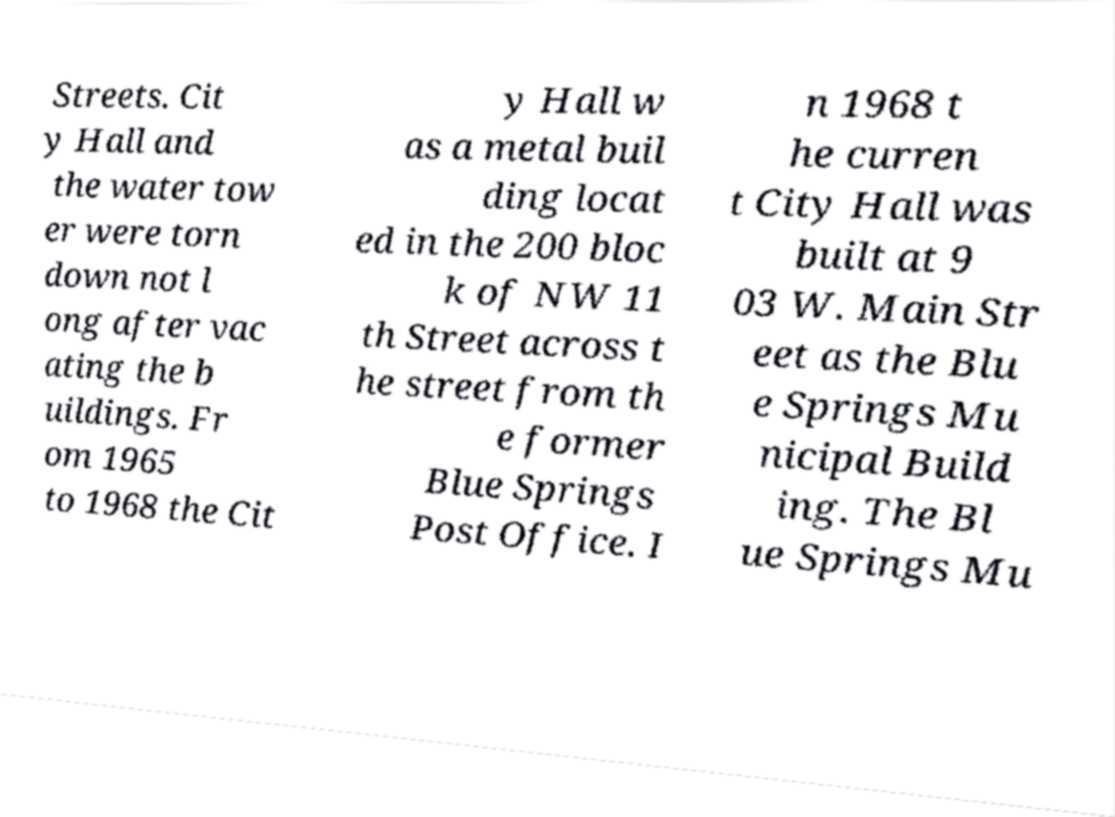Please read and relay the text visible in this image. What does it say? Streets. Cit y Hall and the water tow er were torn down not l ong after vac ating the b uildings. Fr om 1965 to 1968 the Cit y Hall w as a metal buil ding locat ed in the 200 bloc k of NW 11 th Street across t he street from th e former Blue Springs Post Office. I n 1968 t he curren t City Hall was built at 9 03 W. Main Str eet as the Blu e Springs Mu nicipal Build ing. The Bl ue Springs Mu 